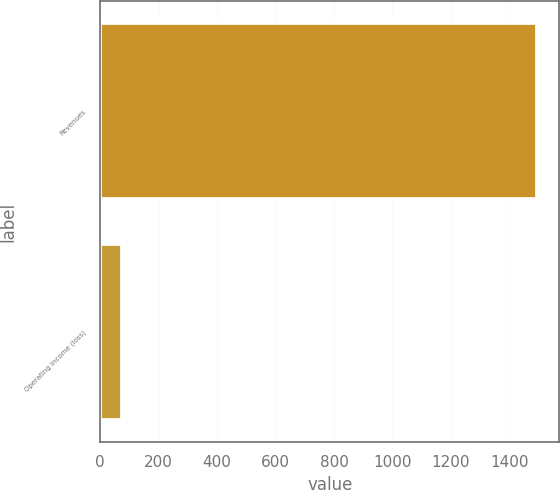Convert chart. <chart><loc_0><loc_0><loc_500><loc_500><bar_chart><fcel>Revenues<fcel>Operating income (loss)<nl><fcel>1496<fcel>76<nl></chart> 